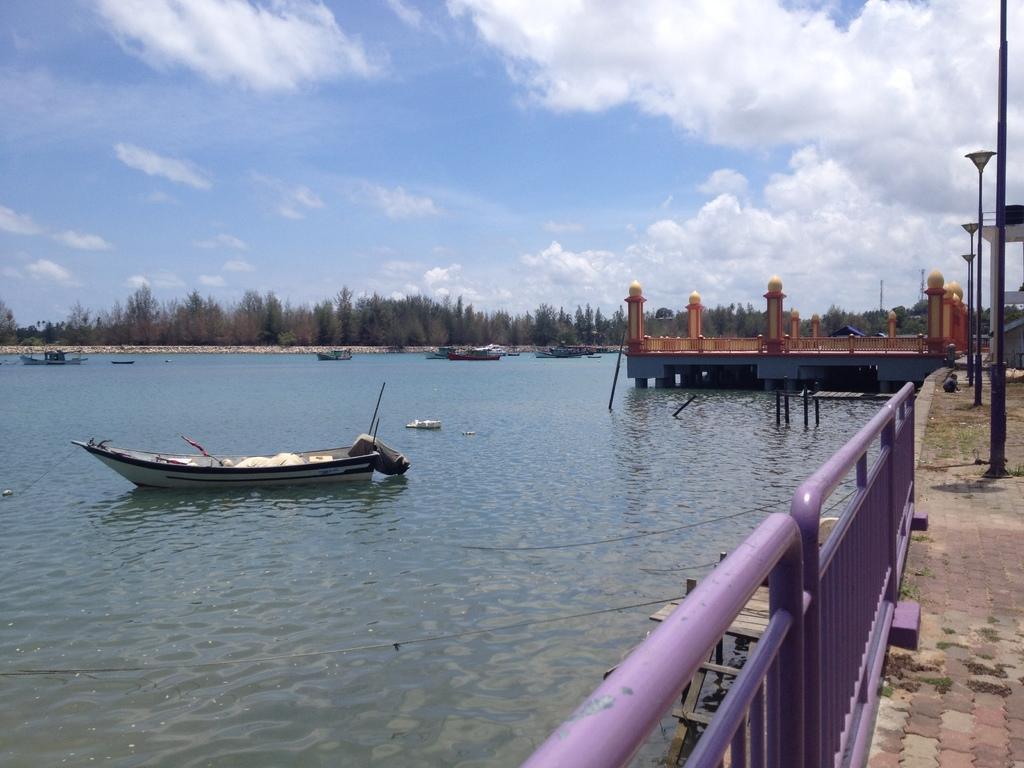How would you summarize this image in a sentence or two? A picture of a river. Sky is cloudy. Far there are number of trees. Boats are floating on water. This is a freshwater river. The fence is in purple color. Poles are line by line. 